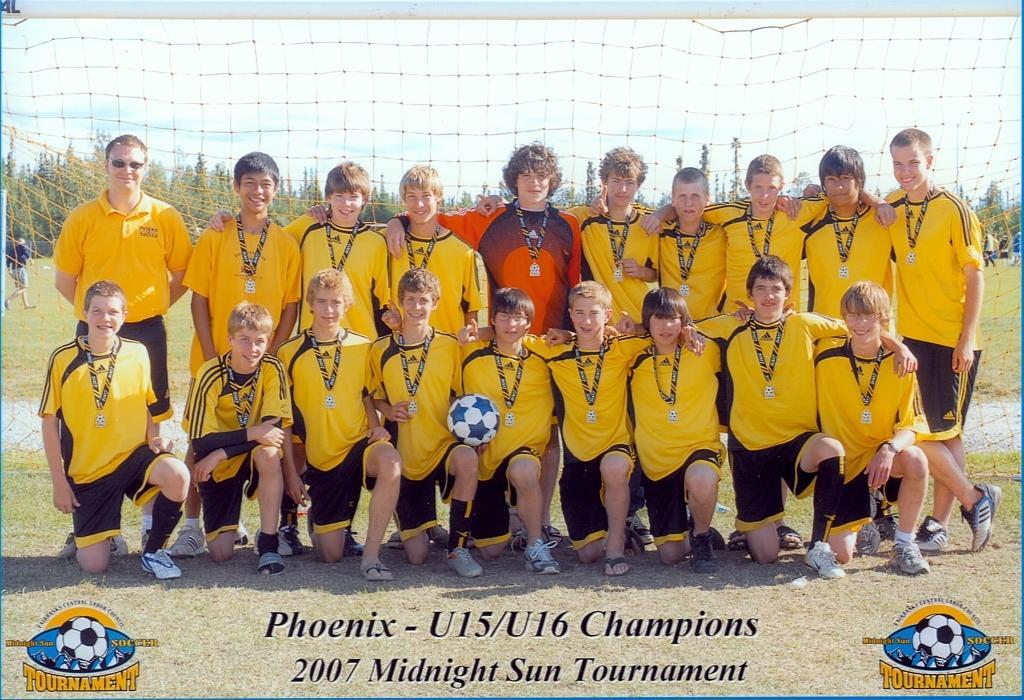Please provide a concise description of this image. This image consists of many people. All are wearing the yellow jerseys. In the middle, the man is wearing an orange jersey. At the bottom, there is text and green grass on the ground. In the background, we can see a goal post along with the trees. At the top, there is the sky. 